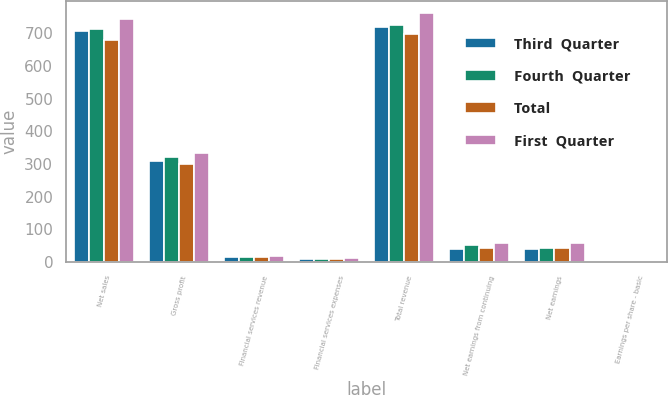<chart> <loc_0><loc_0><loc_500><loc_500><stacked_bar_chart><ecel><fcel>Net sales<fcel>Gross profit<fcel>Financial services revenue<fcel>Financial services expenses<fcel>Total revenue<fcel>Net earnings from continuing<fcel>Net earnings<fcel>Earnings per share - basic<nl><fcel>Third  Quarter<fcel>705.7<fcel>309.9<fcel>13.4<fcel>9.7<fcel>719.1<fcel>38<fcel>39<fcel>0.67<nl><fcel>Fourth  Quarter<fcel>711.9<fcel>322.4<fcel>14.8<fcel>9.7<fcel>726.7<fcel>52.8<fcel>43.8<fcel>0.75<nl><fcel>Total<fcel>680.7<fcel>300.9<fcel>15.8<fcel>10.2<fcel>696.5<fcel>41.1<fcel>41.1<fcel>0.71<nl><fcel>First  Quarter<fcel>742.9<fcel>333.4<fcel>19<fcel>11<fcel>761.9<fcel>57.3<fcel>57.3<fcel>1<nl></chart> 